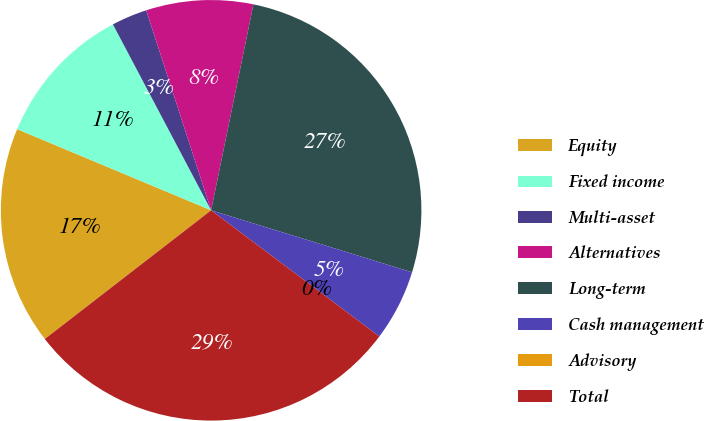Convert chart to OTSL. <chart><loc_0><loc_0><loc_500><loc_500><pie_chart><fcel>Equity<fcel>Fixed income<fcel>Multi-asset<fcel>Alternatives<fcel>Long-term<fcel>Cash management<fcel>Advisory<fcel>Total<nl><fcel>16.79%<fcel>10.96%<fcel>2.74%<fcel>8.22%<fcel>26.54%<fcel>5.48%<fcel>0.0%<fcel>29.28%<nl></chart> 